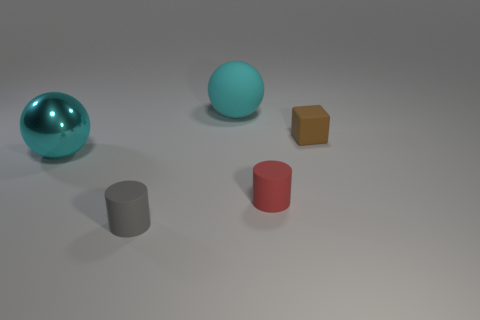Add 3 gray matte objects. How many objects exist? 8 Subtract all spheres. How many objects are left? 3 Subtract all spheres. Subtract all red cylinders. How many objects are left? 2 Add 5 large cyan objects. How many large cyan objects are left? 7 Add 1 big green spheres. How many big green spheres exist? 1 Subtract 0 brown balls. How many objects are left? 5 